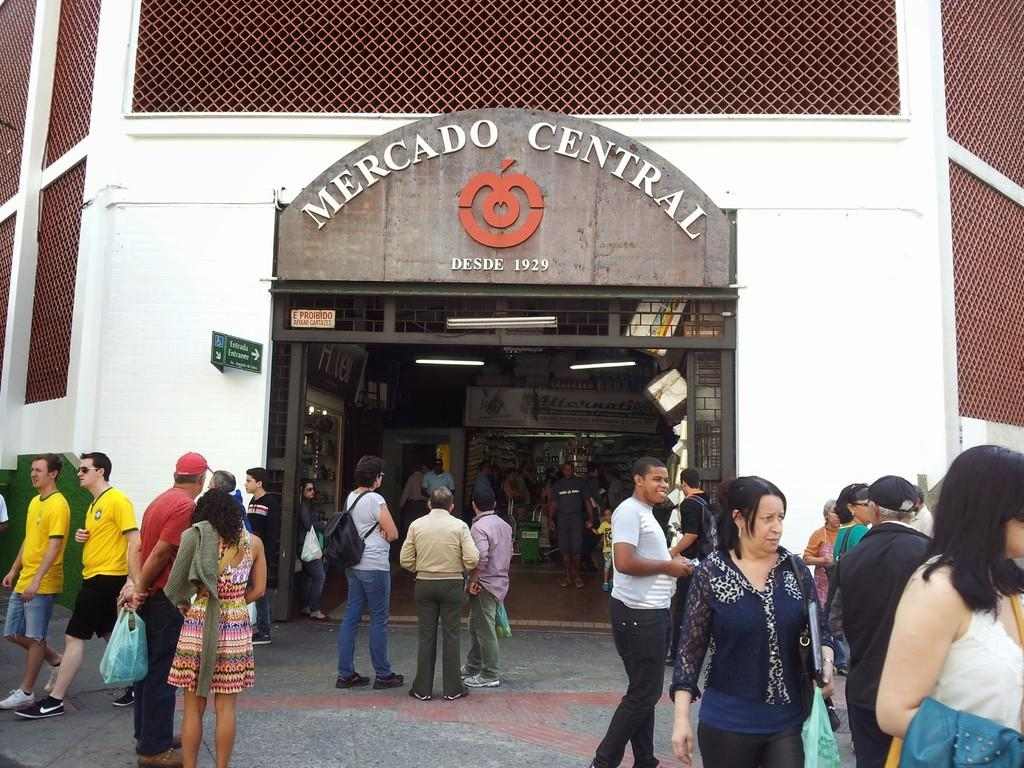<image>
Relay a brief, clear account of the picture shown. Store front of Mercado Central with many people walking in front. 